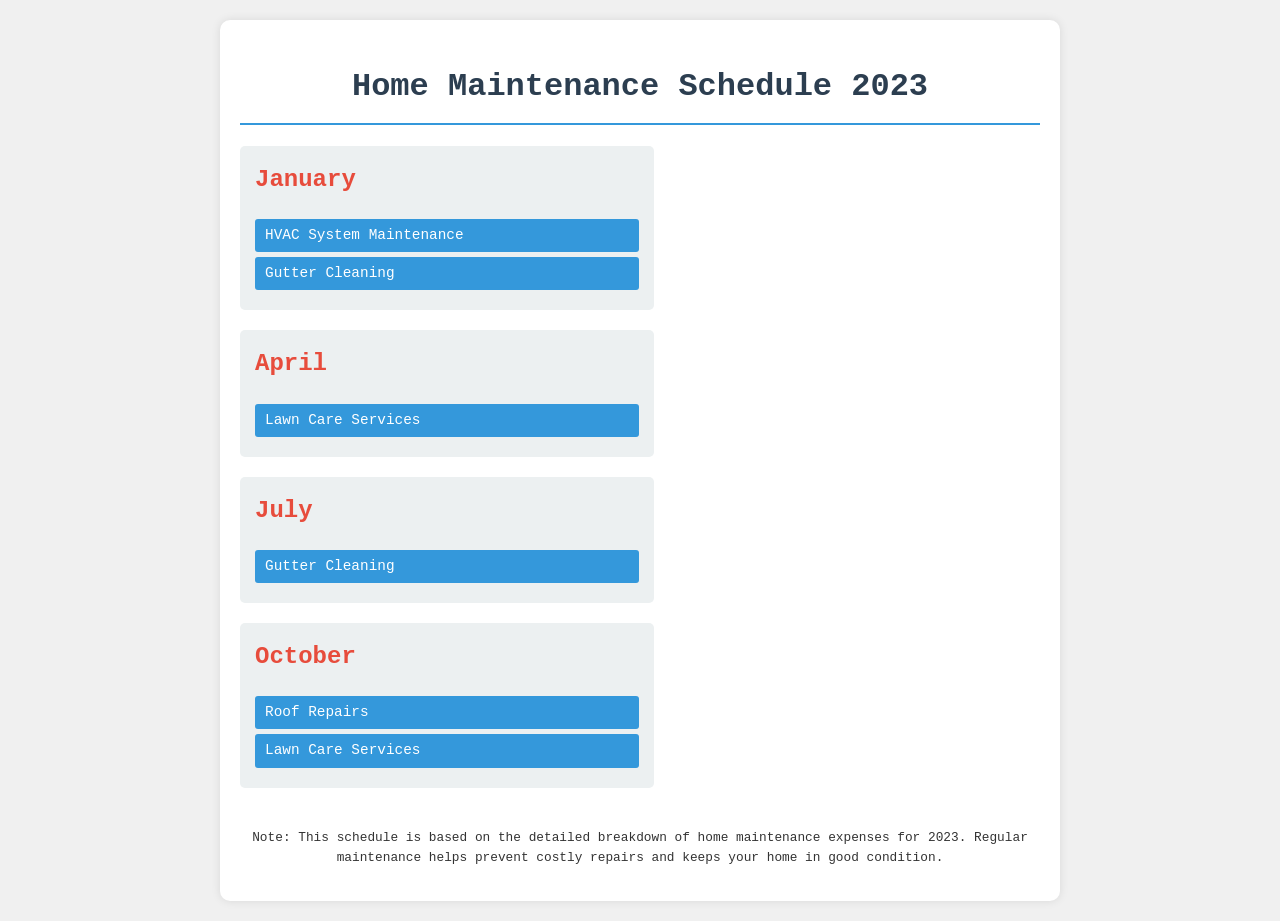What tasks are scheduled for January? The tasks listed for January include HVAC System Maintenance and Gutter Cleaning.
Answer: HVAC System Maintenance, Gutter Cleaning How many tasks are planned for October? The document shows two tasks planned for October, which are Roof Repairs and Lawn Care Services.
Answer: 2 What color is used for the January heading? The heading for January is in red color (#e74c3c).
Answer: Red Which month has Lawn Care Services scheduled twice? The document indicates that Lawn Care Services is scheduled in April and October.
Answer: April, October What is the purpose of the note in the legend? The note explains that regular maintenance helps prevent costly repairs and keeps your home in good condition.
Answer: Prevent costly repairs In which month does Gutter Cleaning occur twice? Gutter Cleaning is scheduled for January and July.
Answer: January, July What is the overall title of the document? The overall title provided at the top of the document is "Home Maintenance Schedule 2023."
Answer: Home Maintenance Schedule 2023 How many months are included in the schedule? The document indicates that there are four months included in the schedule.
Answer: 4 What is the background color of the container? The background color of the container is white.
Answer: White 